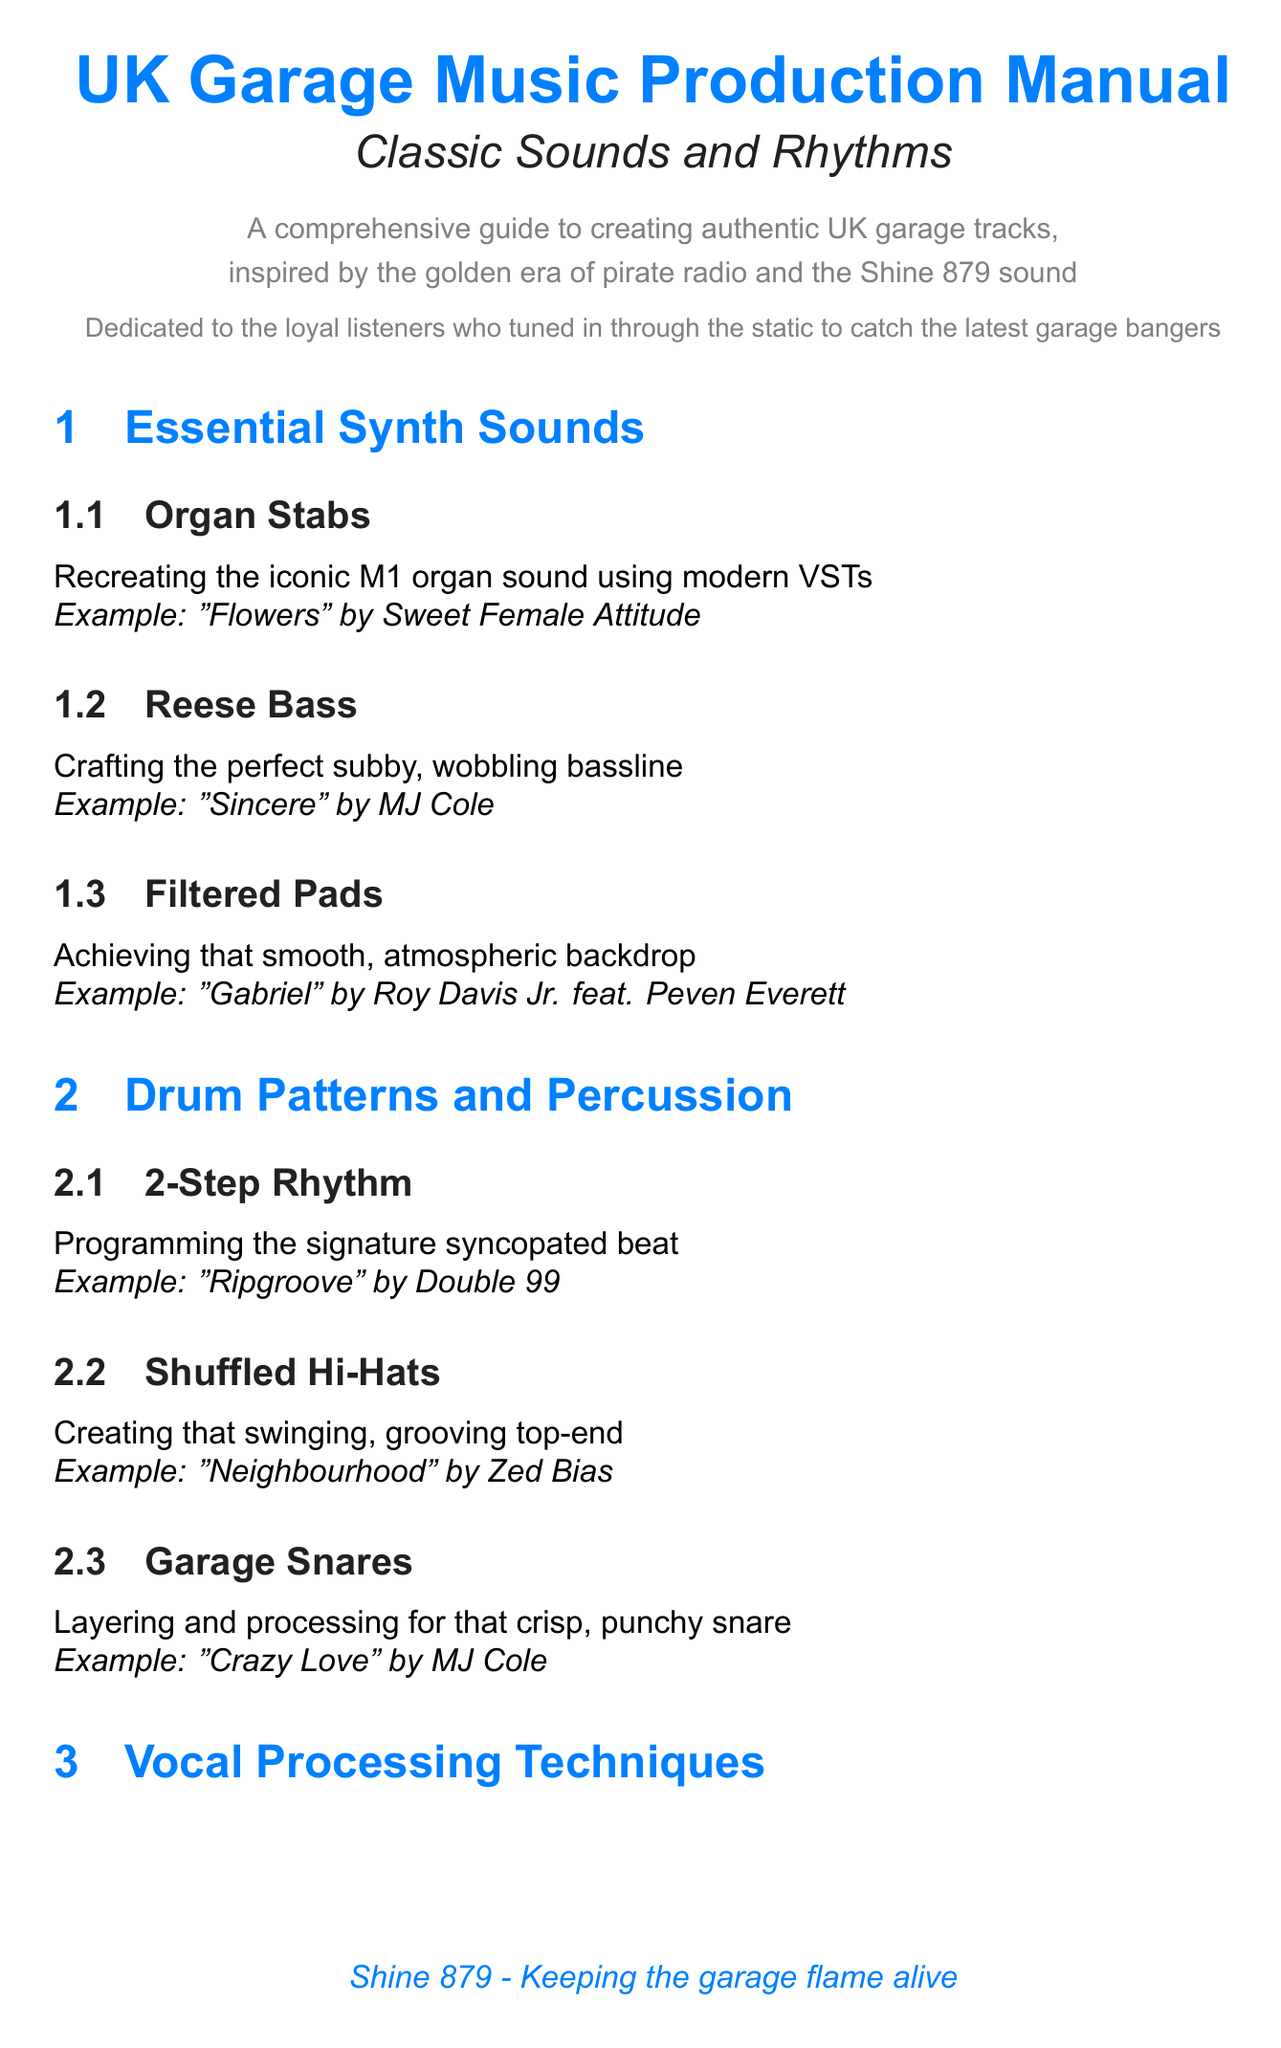What is the title of the manual? The title of the manual is stated at the beginning of the document.
Answer: UK Garage Music Production Manual: Classic Sounds and Rhythms Who is the manual dedicated to? The dedication to the audience is mentioned in the introduction.
Answer: loyal listeners What is the example track for Organ Stabs? The example track is provided in the section about Organ Stabs.
Answer: Flowers by Sweet Female Attitude Which drum pattern is used in "Ripgroove"? The document specifies the drum pattern associated with the track "Ripgroove."
Answer: 2-Step Rhythm What synthesizer is noted for creating organ stabs? This synthesizer is mentioned in the Classic Hardware section for its role in UK garage sound.
Answer: Korg M1 What technique is highlighted for achieving high-pitched vocals? The technique discussed in the Vocal Processing Techniques section is designed to create a specific vocal effect.
Answer: Pitch-Shifting How many sections are in the "Drum Patterns and Percussion" chapter? The number of sections can be counted directly from the chapter description.
Answer: 3 What type of effects unit is the Alesis Quadraverb? The manual describes the Alesis Quadraverb's role in the garage sound.
Answer: effects unit What is one of the references for EQ in AM Transmission? The specific reference provided gives insight into the document's sources.
Answer: Tips from the Shine 879 studio engineers 